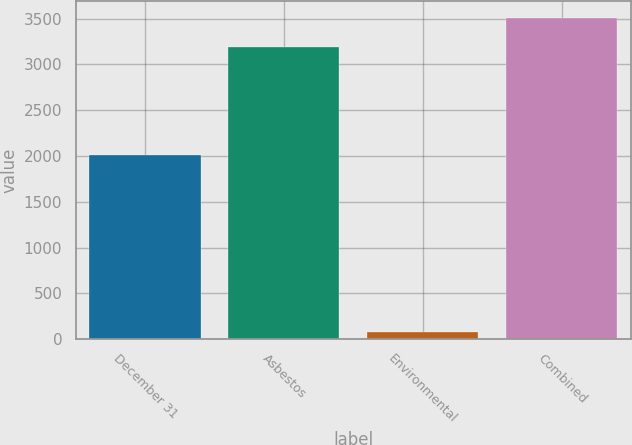<chart> <loc_0><loc_0><loc_500><loc_500><bar_chart><fcel>December 31<fcel>Asbestos<fcel>Environmental<fcel>Combined<nl><fcel>2012<fcel>3193<fcel>75<fcel>3512.3<nl></chart> 